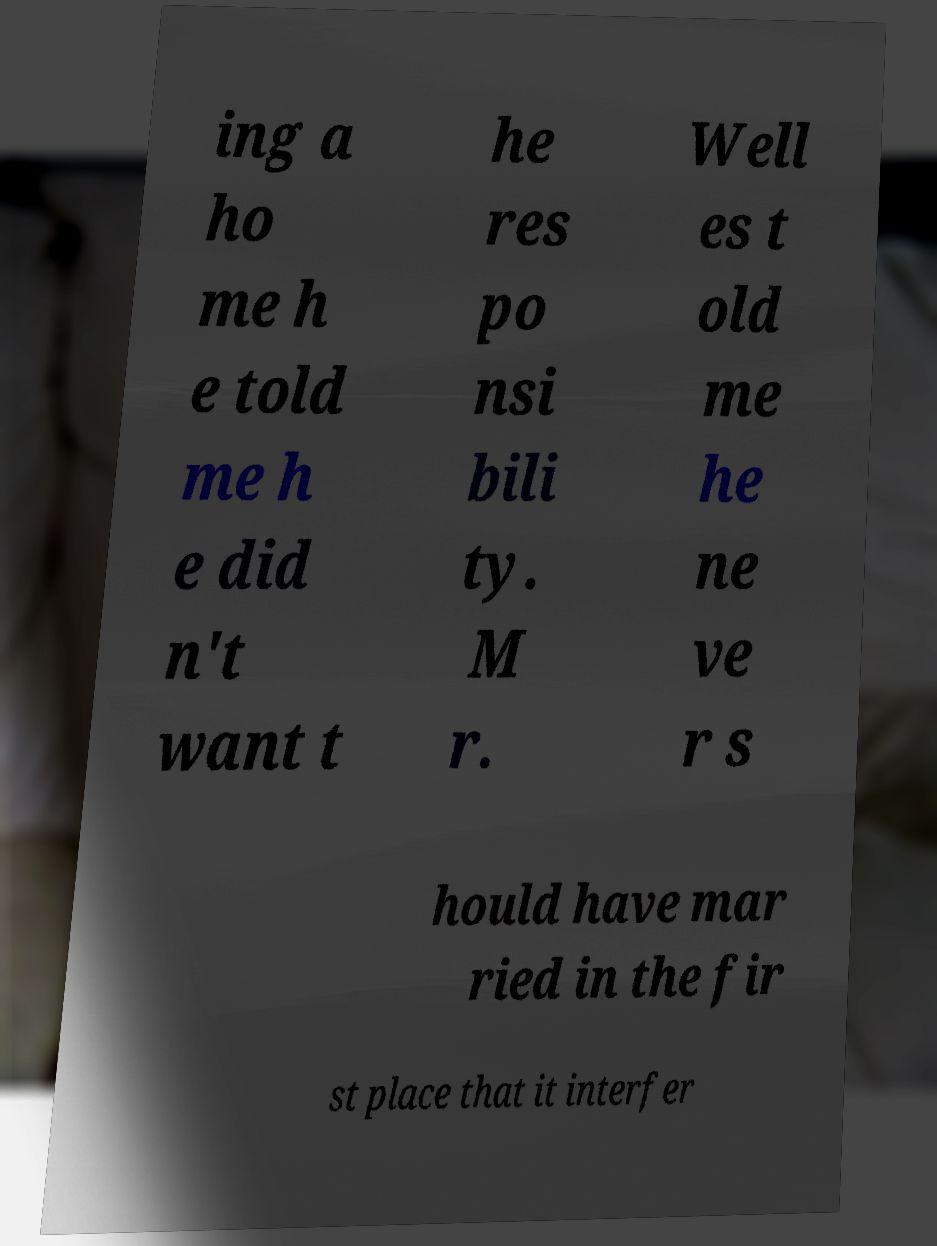For documentation purposes, I need the text within this image transcribed. Could you provide that? ing a ho me h e told me h e did n't want t he res po nsi bili ty. M r. Well es t old me he ne ve r s hould have mar ried in the fir st place that it interfer 